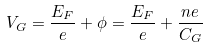Convert formula to latex. <formula><loc_0><loc_0><loc_500><loc_500>V _ { G } = \frac { E _ { F } } { e } + \phi = \frac { E _ { F } } { e } + \frac { n e } { C _ { G } }</formula> 